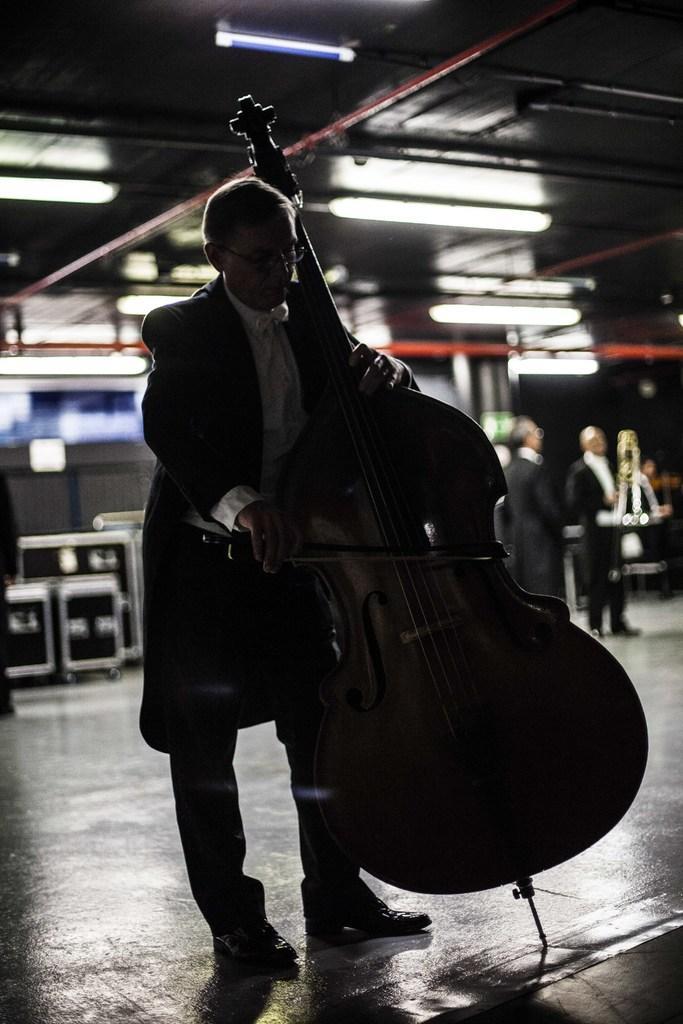How would you summarize this image in a sentence or two? In this image, there is an inside view of a building. There is a person standing and playing a musical instrument. This person is wearing clothes and footwear. There are two persons on the right side of the image. There are some lights at the top. 